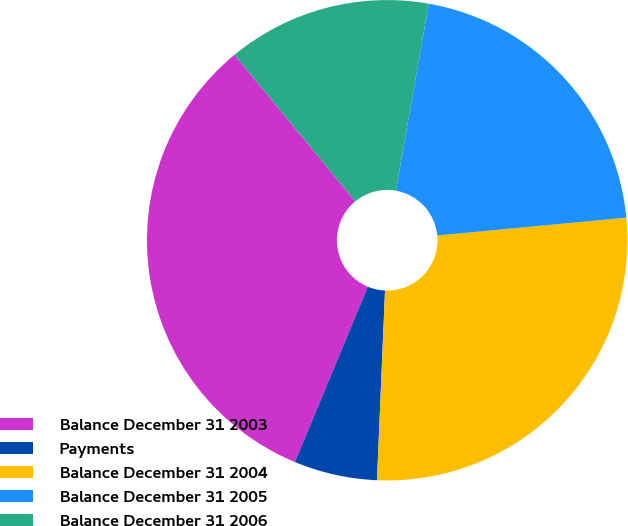<chart> <loc_0><loc_0><loc_500><loc_500><pie_chart><fcel>Balance December 31 2003<fcel>Payments<fcel>Balance December 31 2004<fcel>Balance December 31 2005<fcel>Balance December 31 2006<nl><fcel>32.77%<fcel>5.6%<fcel>27.17%<fcel>20.73%<fcel>13.73%<nl></chart> 